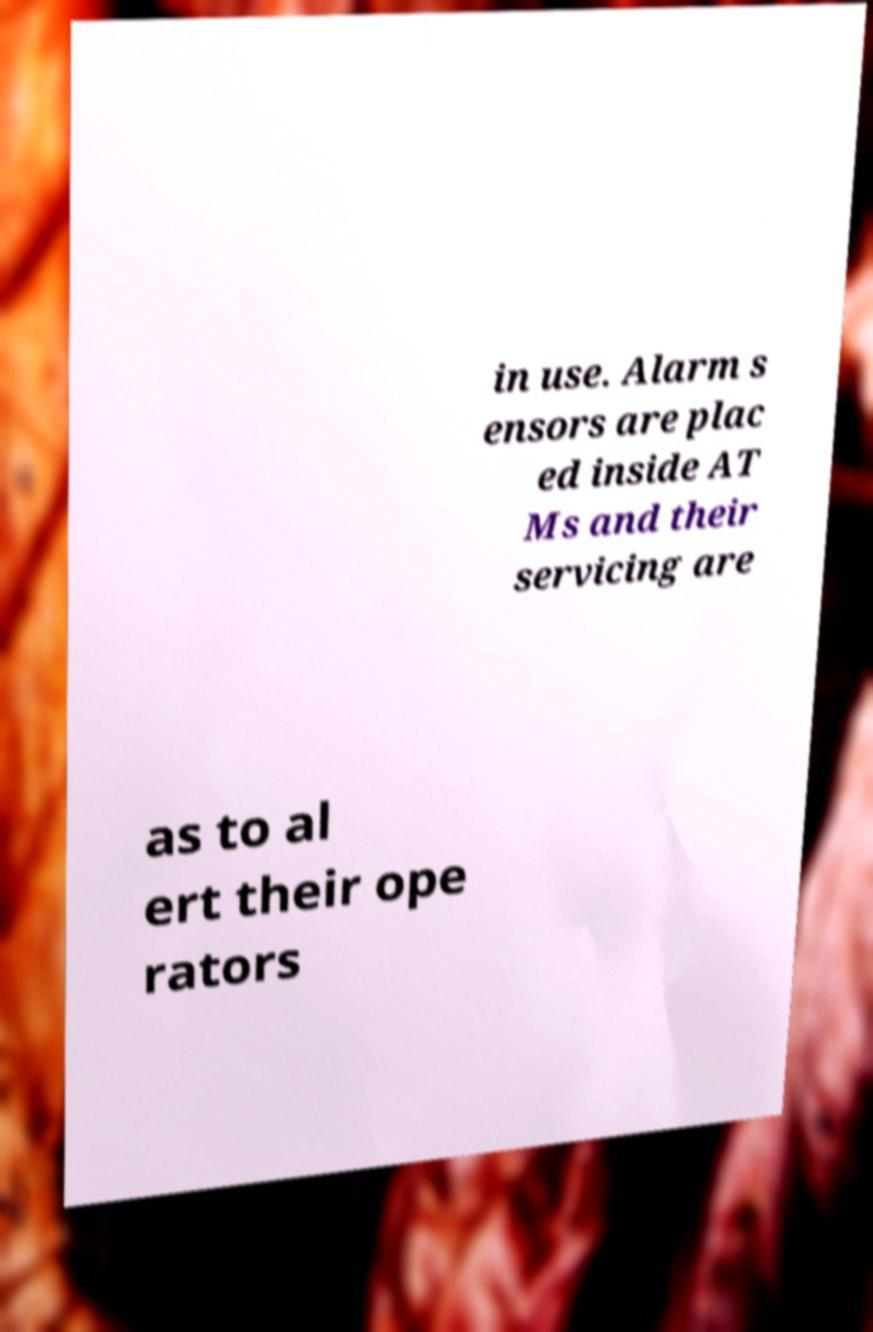What messages or text are displayed in this image? I need them in a readable, typed format. in use. Alarm s ensors are plac ed inside AT Ms and their servicing are as to al ert their ope rators 